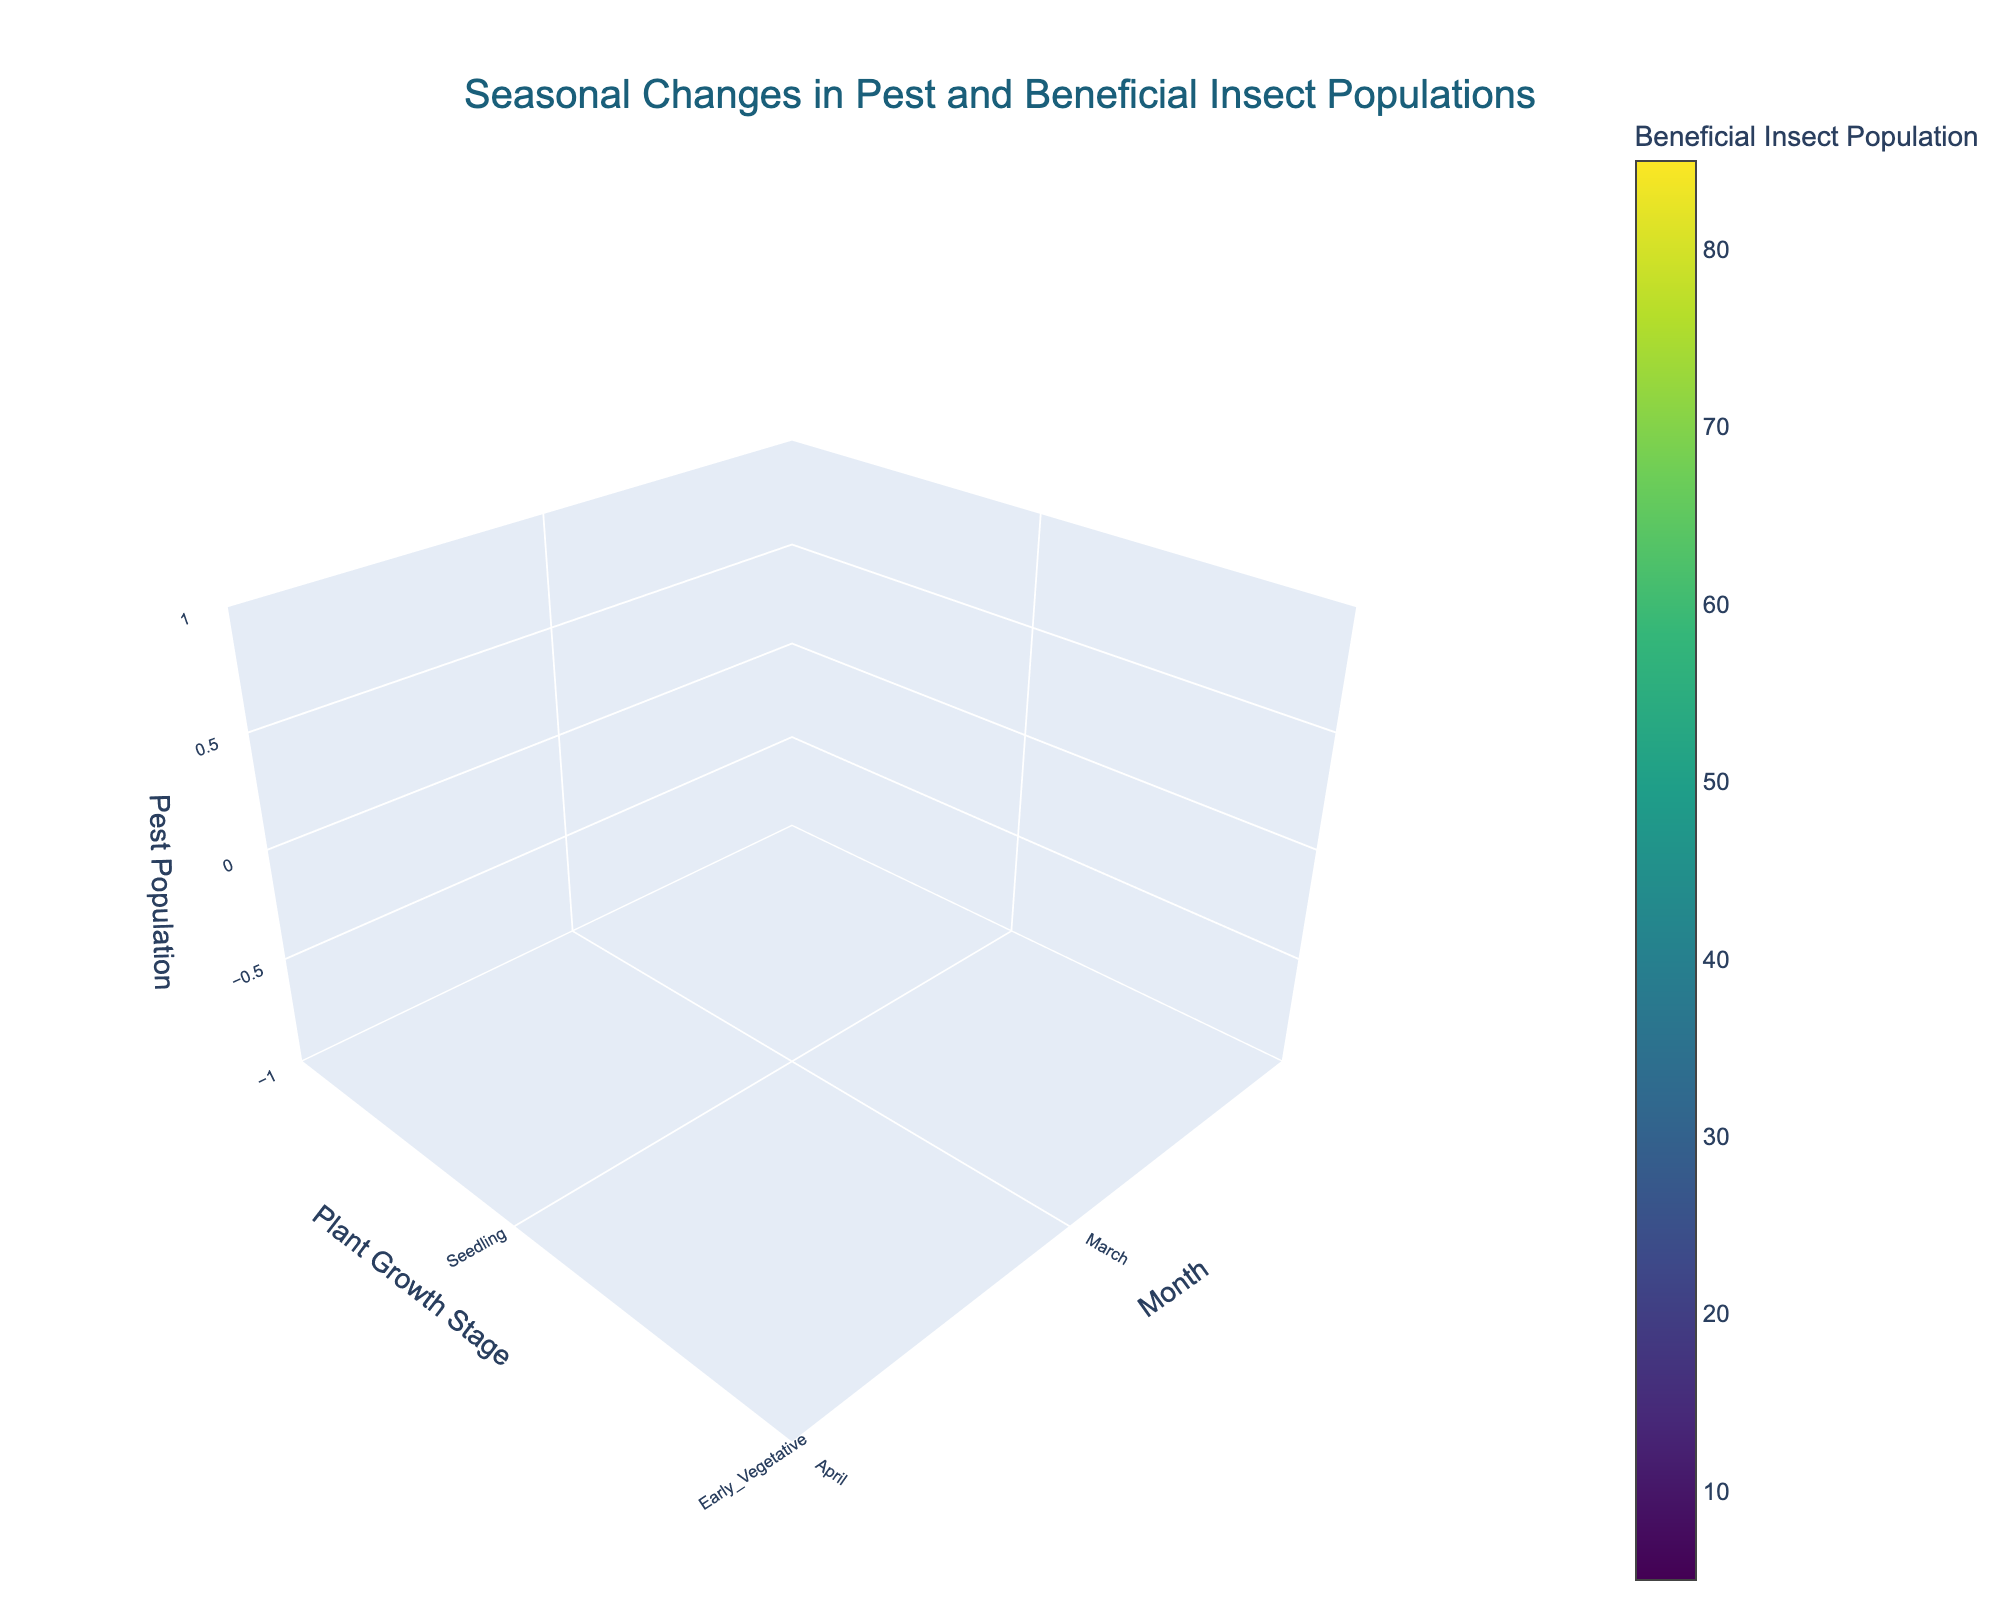What is the title of the figure? The title of the figure is usually placed at the top center of the plot.
Answer: Seasonal Changes in Pest and Beneficial Insect Populations What do the axes represent? The axes labels describe what each axis represents: the x-axis is "Month," the y-axis is "Plant Growth Stage," and the z-axis is "Pest Population."
Answer: The x-axis represents "Month," the y-axis represents "Plant Growth Stage," and the z-axis represents "Pest Population." When is the pest population highest? By examining the z-axis in relation to the months, we observe that the highest pest population is in July during Peak Flowering.
Answer: July, Peak Flowering How many plant growth stages are shown in the figure? Look at the y-axis to count the distinct plant growth stages marking each month. There are nine stages: Seedling, Early Vegetative, Late Vegetative, Early Flowering, Peak Flowering, Early Fruiting, Late Fruiting, Senescence, and Dormancy.
Answer: Nine In which month is the beneficial insect population at its peak? By investigating the color intensity in relation to different months, we find that the peak in beneficial insect population occurs in August during Early Fruiting.
Answer: August, Early Fruiting What is the beneficial insect population in March? Referring to the color scale and the point corresponding to March and Seedling growth stage, we see that the beneficial insect population is 5.
Answer: 5 How does the pest population change from May to June? Comparing the z-axis value for May (Late Vegetative) and June (Early Flowering), the pest population increases from 50 to 80.
Answer: The pest population increases by 30 How do the pest and beneficial insect populations change from Early Fruiting to Late Fruiting stages? In Early Fruiting (August), the pest population is 90 and beneficial insect population is 85. In Late Fruiting (September), the pest population decreases to 70 while the beneficial insect population slightly decreases to 80.
Answer: Pest population decreases by 20; Beneficial insect population decreases by 5 In which plant growth stage do the pest and beneficial insect populations both reach their peak values? Checking the z-axis (pest population) and color scale (beneficial insect population), both populations peak during Peak Flowering in July.
Answer: Peak Flowering (July) 